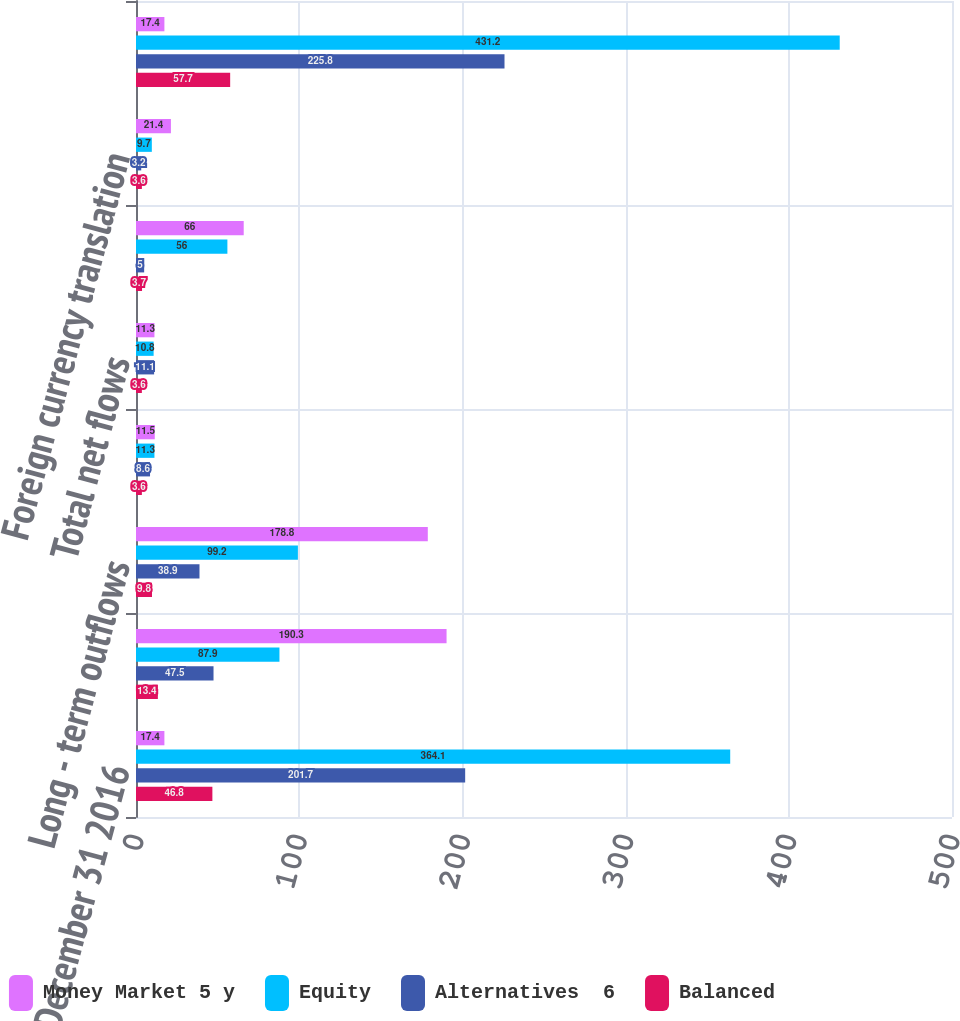Convert chart to OTSL. <chart><loc_0><loc_0><loc_500><loc_500><stacked_bar_chart><ecel><fcel>December 31 2016<fcel>Long - term inflows (2)<fcel>Long - term outflows<fcel>Long - term net flows<fcel>Total net flows<fcel>Market gains and losses (2)<fcel>Foreign currency translation<fcel>December 31 2017<nl><fcel>Money Market 5 y<fcel>17.4<fcel>190.3<fcel>178.8<fcel>11.5<fcel>11.3<fcel>66<fcel>21.4<fcel>17.4<nl><fcel>Equity<fcel>364.1<fcel>87.9<fcel>99.2<fcel>11.3<fcel>10.8<fcel>56<fcel>9.7<fcel>431.2<nl><fcel>Alternatives  6<fcel>201.7<fcel>47.5<fcel>38.9<fcel>8.6<fcel>11.1<fcel>5<fcel>3.2<fcel>225.8<nl><fcel>Balanced<fcel>46.8<fcel>13.4<fcel>9.8<fcel>3.6<fcel>3.6<fcel>3.7<fcel>3.6<fcel>57.7<nl></chart> 